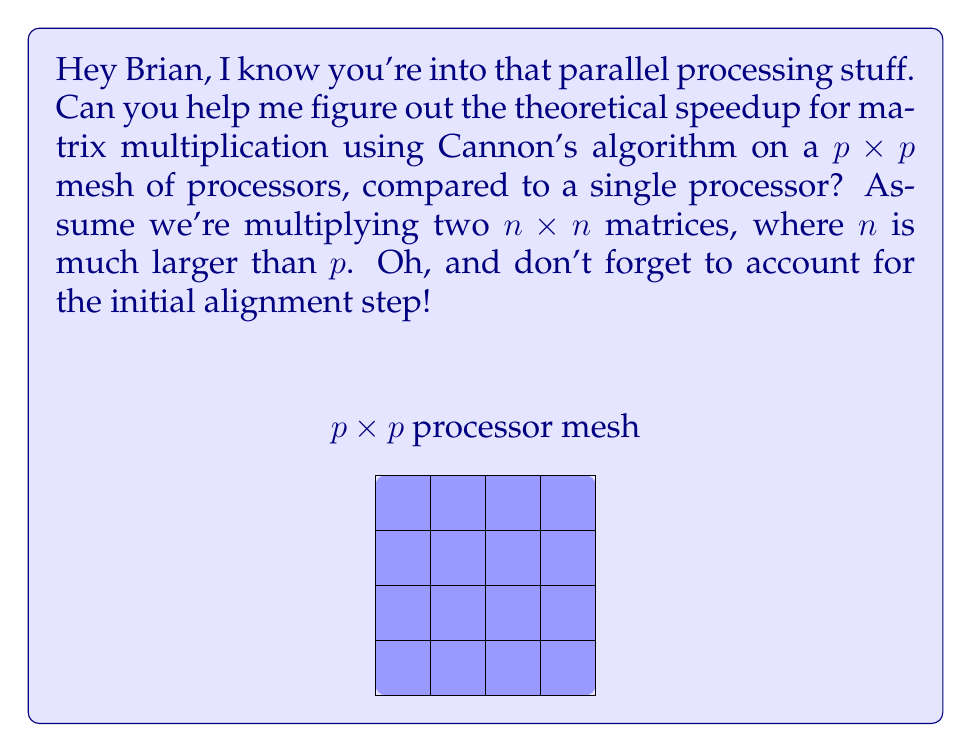Give your solution to this math problem. Alright, let's break this down step-by-step:

1) First, recall that sequential matrix multiplication for $n \times n$ matrices takes $O(n^3)$ time.

2) Cannon's algorithm divides the work among $p^2$ processors in a $p \times p$ mesh.

3) The algorithm has two main phases:
   a) Initial alignment: $O(n/p)$ time
   b) Computation: $O(n^3/(p^2))$ time

4) The computation phase dominates for large $n$, so we'll focus on that.

5) Theoretical speedup is defined as:
   $S = \frac{\text{Time on single processor}}{\text{Time on parallel system}}$

6) Substituting our time complexities:

   $S = \frac{O(n^3)}{O(n^3/p^2)} = O(p^2)$

7) However, we need to account for the initial alignment step. This adds $O(n/p)$ to the parallel time, giving us:

   $S = \frac{O(n^3)}{O(n^3/p^2 + n/p)}$

8) For large $n$, the $n/p$ term becomes negligible compared to $n^3/p^2$, so our final speedup is still approximately $O(p^2)$.
Answer: $O(p^2)$ 